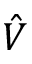Convert formula to latex. <formula><loc_0><loc_0><loc_500><loc_500>\hat { V }</formula> 